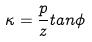Convert formula to latex. <formula><loc_0><loc_0><loc_500><loc_500>\kappa = \frac { p } { z } t a n \phi</formula> 